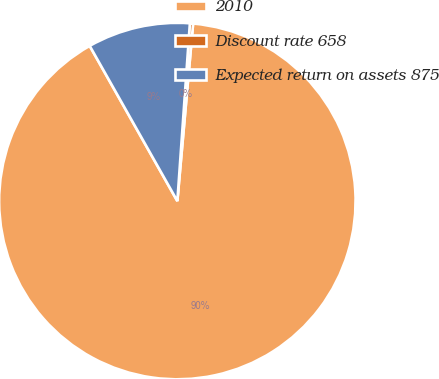Convert chart to OTSL. <chart><loc_0><loc_0><loc_500><loc_500><pie_chart><fcel>2010<fcel>Discount rate 658<fcel>Expected return on assets 875<nl><fcel>90.41%<fcel>0.29%<fcel>9.3%<nl></chart> 